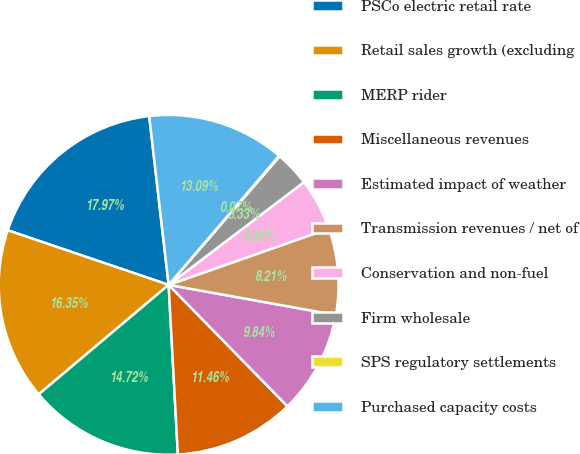Convert chart. <chart><loc_0><loc_0><loc_500><loc_500><pie_chart><fcel>PSCo electric retail rate<fcel>Retail sales growth (excluding<fcel>MERP rider<fcel>Miscellaneous revenues<fcel>Estimated impact of weather<fcel>Transmission revenues / net of<fcel>Conservation and non-fuel<fcel>Firm wholesale<fcel>SPS regulatory settlements<fcel>Purchased capacity costs<nl><fcel>17.97%<fcel>16.35%<fcel>14.72%<fcel>11.46%<fcel>9.84%<fcel>8.21%<fcel>4.96%<fcel>3.33%<fcel>0.07%<fcel>13.09%<nl></chart> 